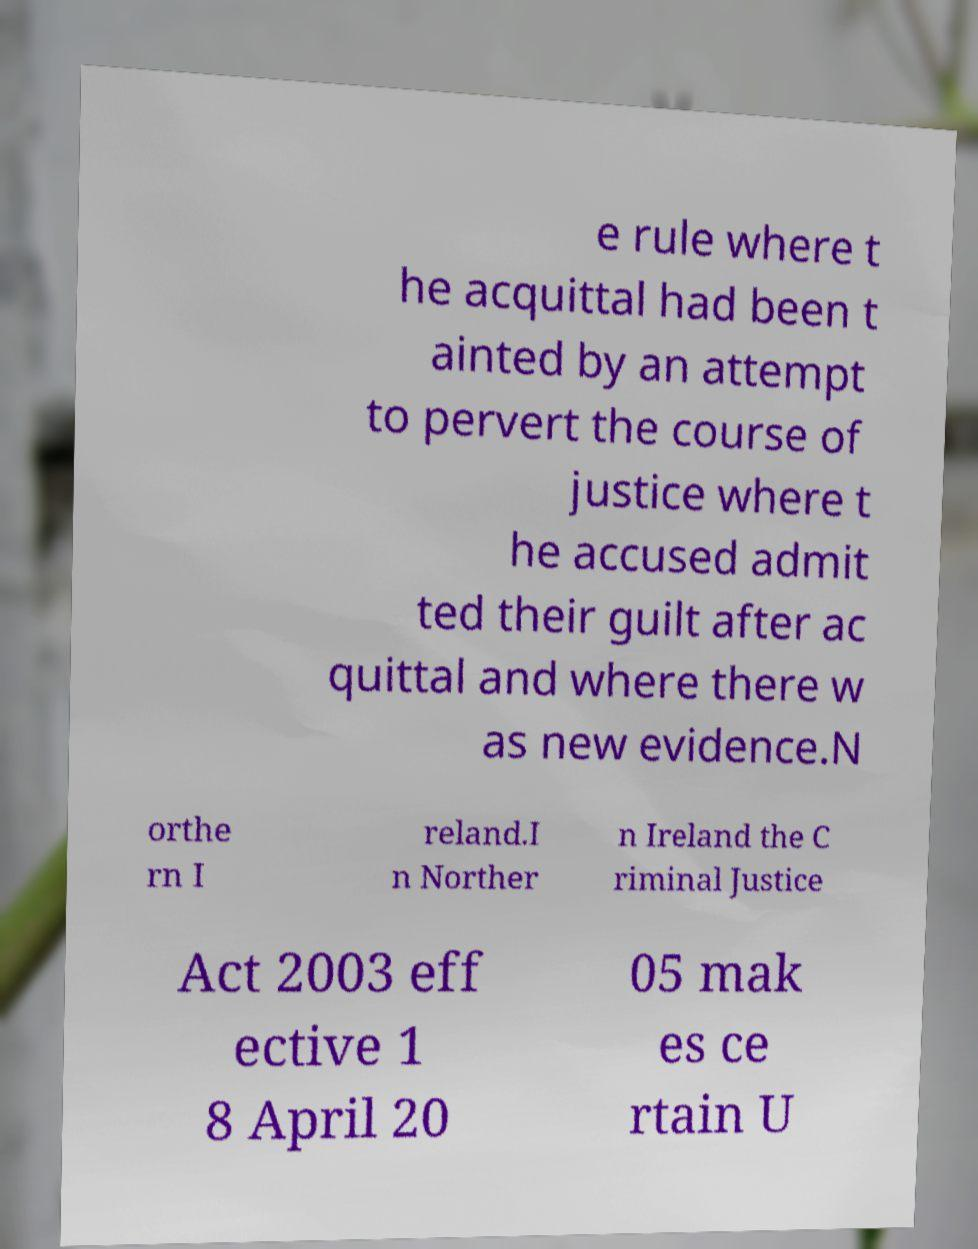Can you read and provide the text displayed in the image?This photo seems to have some interesting text. Can you extract and type it out for me? e rule where t he acquittal had been t ainted by an attempt to pervert the course of justice where t he accused admit ted their guilt after ac quittal and where there w as new evidence.N orthe rn I reland.I n Norther n Ireland the C riminal Justice Act 2003 eff ective 1 8 April 20 05 mak es ce rtain U 